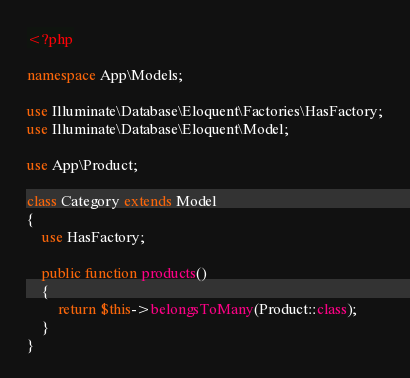<code> <loc_0><loc_0><loc_500><loc_500><_PHP_><?php

namespace App\Models;

use Illuminate\Database\Eloquent\Factories\HasFactory;
use Illuminate\Database\Eloquent\Model;

use App\Product;

class Category extends Model
{
    use HasFactory;

    public function products()
    {
        return $this->belongsToMany(Product::class);
    }
}
</code> 